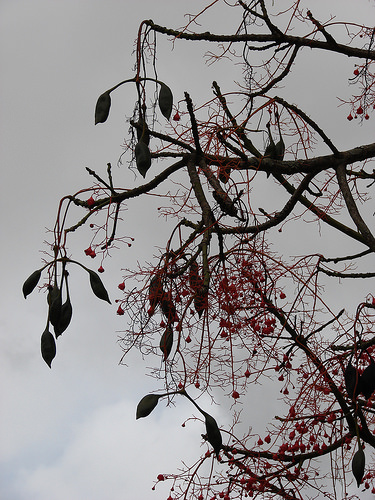<image>
Is there a fruit above the sky? No. The fruit is not positioned above the sky. The vertical arrangement shows a different relationship. 